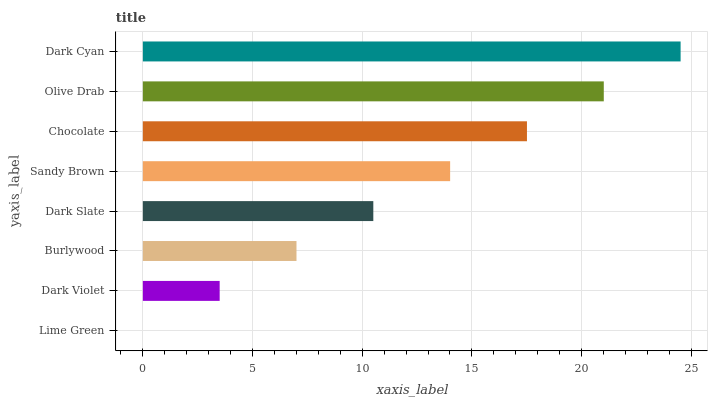Is Lime Green the minimum?
Answer yes or no. Yes. Is Dark Cyan the maximum?
Answer yes or no. Yes. Is Dark Violet the minimum?
Answer yes or no. No. Is Dark Violet the maximum?
Answer yes or no. No. Is Dark Violet greater than Lime Green?
Answer yes or no. Yes. Is Lime Green less than Dark Violet?
Answer yes or no. Yes. Is Lime Green greater than Dark Violet?
Answer yes or no. No. Is Dark Violet less than Lime Green?
Answer yes or no. No. Is Sandy Brown the high median?
Answer yes or no. Yes. Is Dark Slate the low median?
Answer yes or no. Yes. Is Olive Drab the high median?
Answer yes or no. No. Is Dark Cyan the low median?
Answer yes or no. No. 